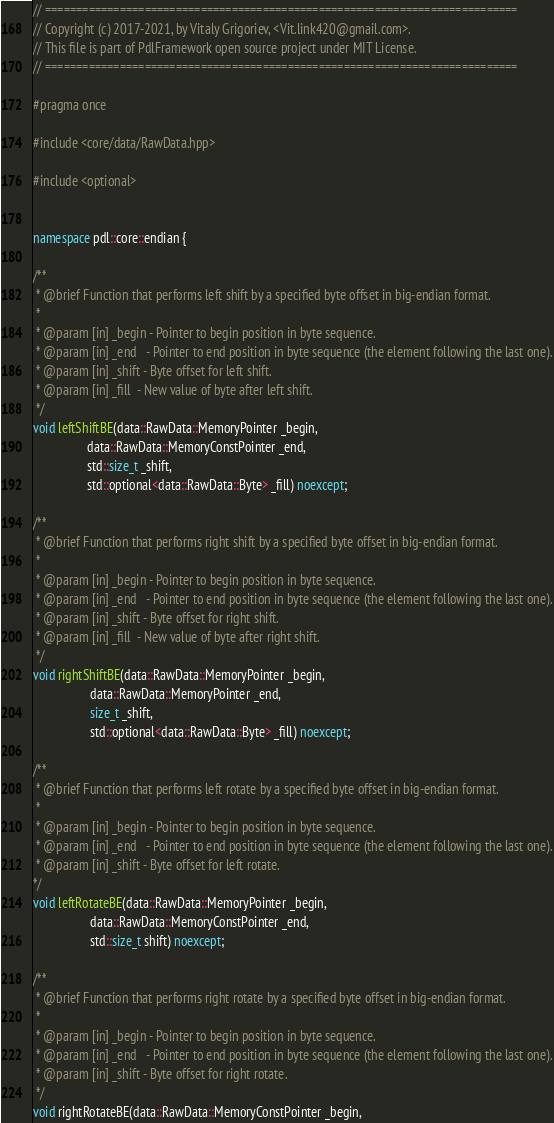<code> <loc_0><loc_0><loc_500><loc_500><_C++_>// ============================================================================
// Copyright (c) 2017-2021, by Vitaly Grigoriev, <Vit.link420@gmail.com>.
// This file is part of PdlFramework open source project under MIT License.
// ============================================================================

#pragma once

#include <core/data/RawData.hpp>

#include <optional>


namespace pdl::core::endian {

/**
 * @brief Function that performs left shift by a specified byte offset in big-endian format.
 *
 * @param [in] _begin - Pointer to begin position in byte sequence.
 * @param [in] _end   - Pointer to end position in byte sequence (the element following the last one).
 * @param [in] _shift - Byte offset for left shift.
 * @param [in] _fill  - New value of byte after left shift.
 */
void leftShiftBE(data::RawData::MemoryPointer _begin,
                 data::RawData::MemoryConstPointer _end,
                 std::size_t _shift,
                 std::optional<data::RawData::Byte> _fill) noexcept;

/**
 * @brief Function that performs right shift by a specified byte offset in big-endian format.
 *
 * @param [in] _begin - Pointer to begin position in byte sequence.
 * @param [in] _end   - Pointer to end position in byte sequence (the element following the last one).
 * @param [in] _shift - Byte offset for right shift.
 * @param [in] _fill  - New value of byte after right shift.
 */
void rightShiftBE(data::RawData::MemoryPointer _begin,
                  data::RawData::MemoryPointer _end,
                  size_t _shift,
                  std::optional<data::RawData::Byte> _fill) noexcept;

/**
 * @brief Function that performs left rotate by a specified byte offset in big-endian format.
 *
 * @param [in] _begin - Pointer to begin position in byte sequence.
 * @param [in] _end   - Pointer to end position in byte sequence (the element following the last one).
 * @param [in] _shift - Byte offset for left rotate.
*/
void leftRotateBE(data::RawData::MemoryPointer _begin,
                  data::RawData::MemoryConstPointer _end,
                  std::size_t shift) noexcept;

/**
 * @brief Function that performs right rotate by a specified byte offset in big-endian format.
 *
 * @param [in] _begin - Pointer to begin position in byte sequence.
 * @param [in] _end   - Pointer to end position in byte sequence (the element following the last one).
 * @param [in] _shift - Byte offset for right rotate.
 */
void rightRotateBE(data::RawData::MemoryConstPointer _begin,</code> 